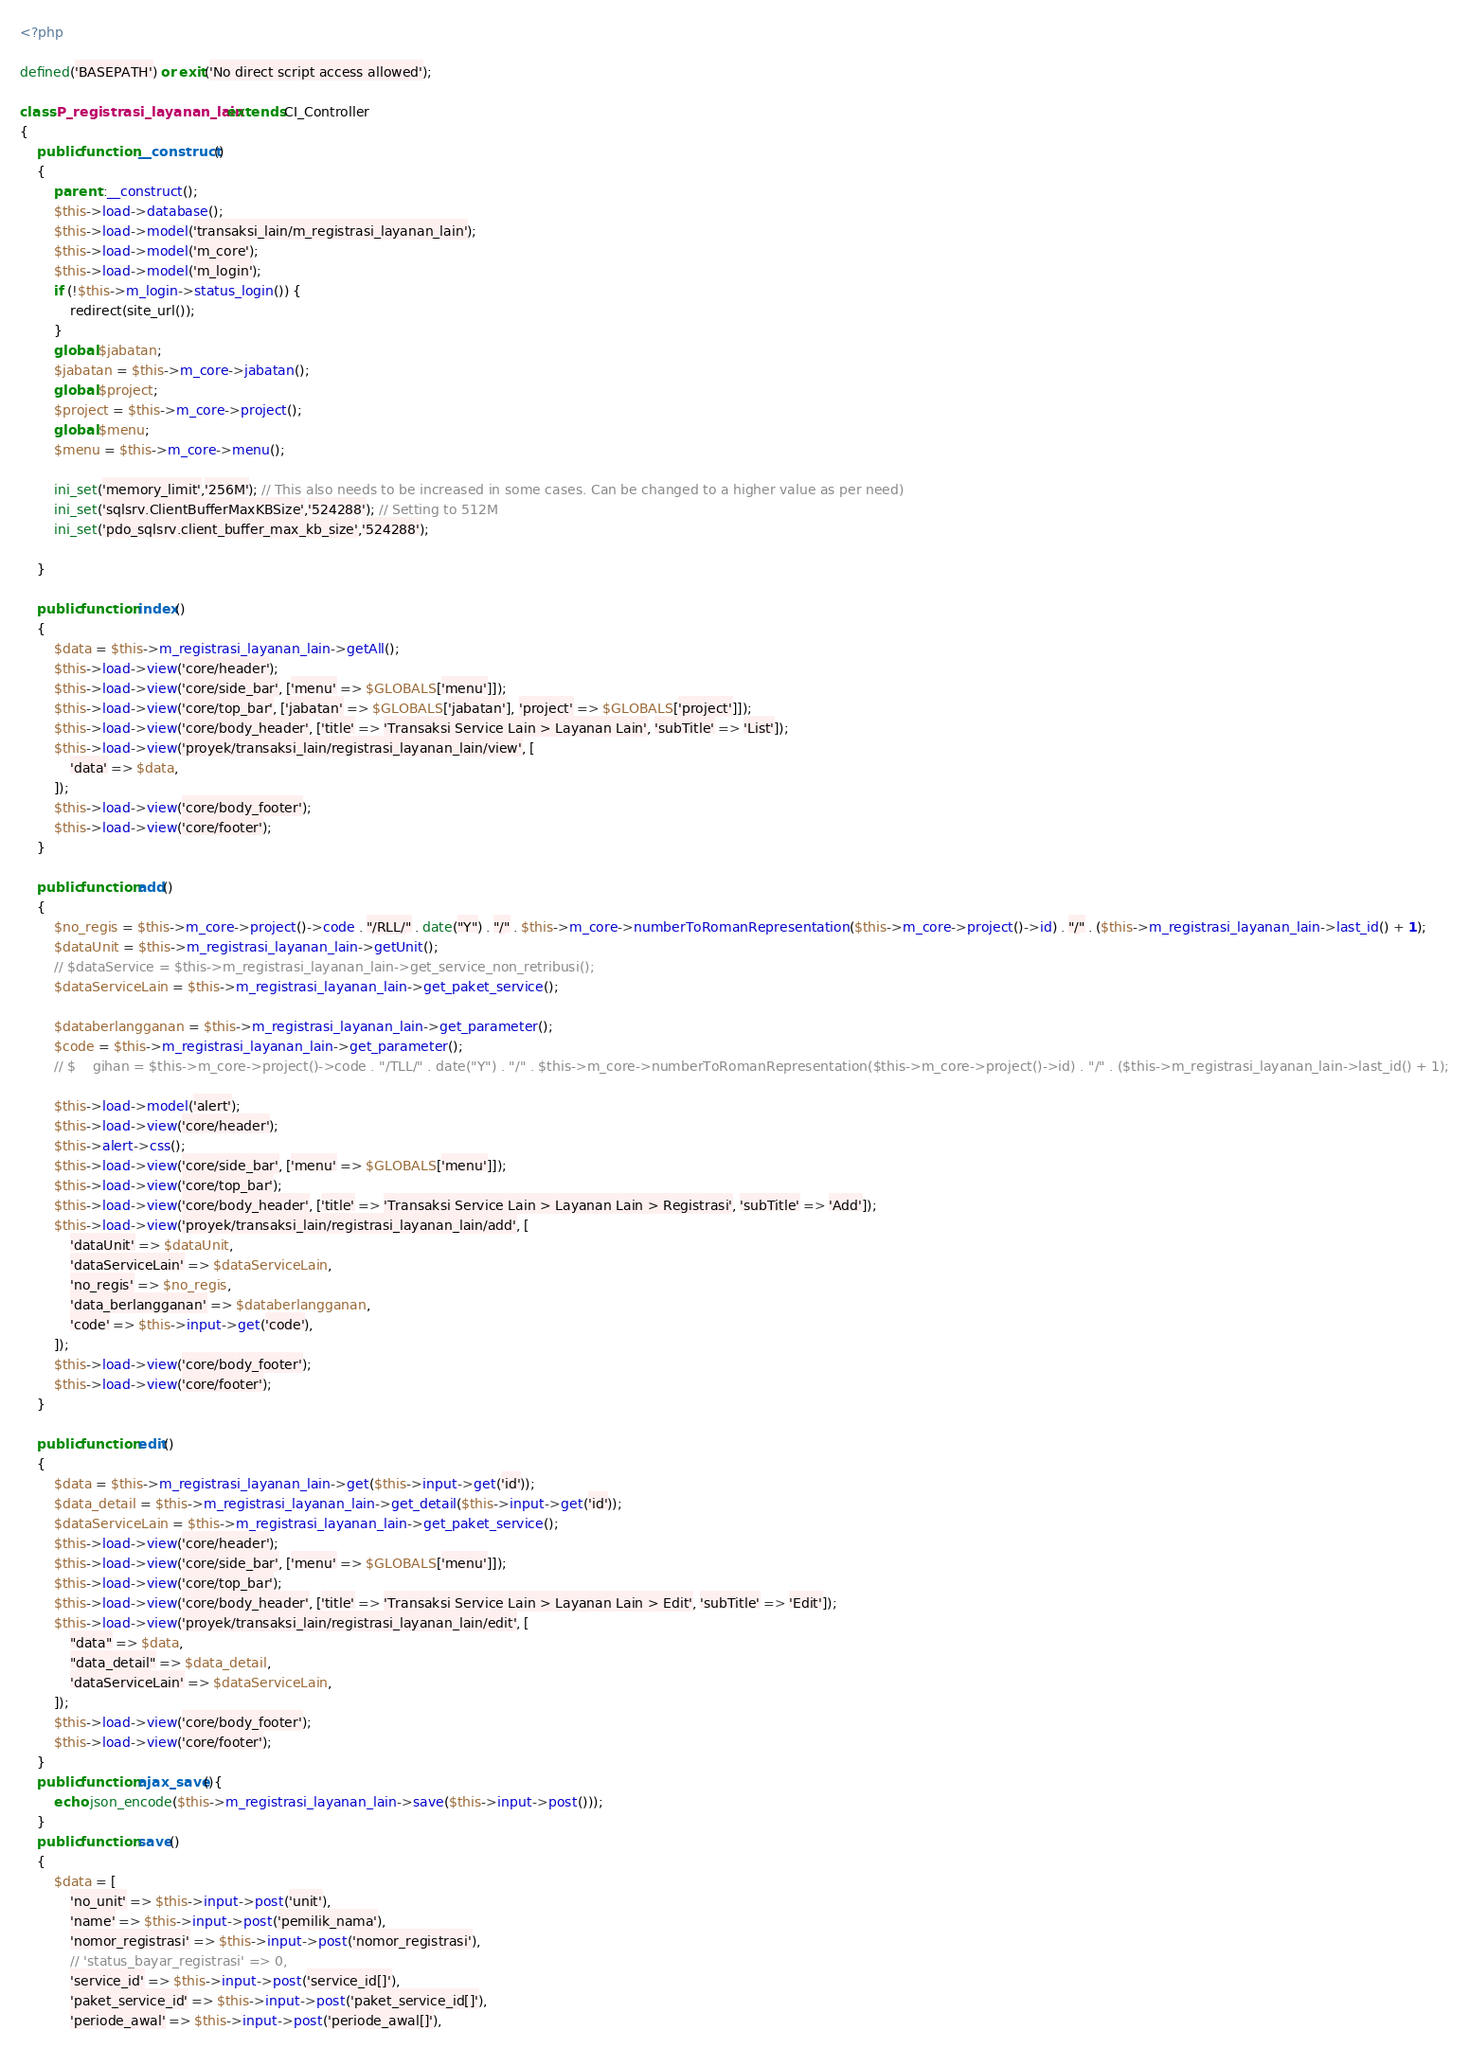Convert code to text. <code><loc_0><loc_0><loc_500><loc_500><_PHP_><?php

defined('BASEPATH') or exit('No direct script access allowed');

class P_registrasi_layanan_lain extends CI_Controller
{
    public function __construct()
    {
        parent::__construct();
        $this->load->database();
        $this->load->model('transaksi_lain/m_registrasi_layanan_lain');
        $this->load->model('m_core');
        $this->load->model('m_login');
        if (!$this->m_login->status_login()) {
            redirect(site_url());
        }
        global $jabatan;
        $jabatan = $this->m_core->jabatan();
        global $project;
        $project = $this->m_core->project();
        global $menu;
        $menu = $this->m_core->menu();
        
		ini_set('memory_limit','256M'); // This also needs to be increased in some cases. Can be changed to a higher value as per need)
        ini_set('sqlsrv.ClientBufferMaxKBSize','524288'); // Setting to 512M
        ini_set('pdo_sqlsrv.client_buffer_max_kb_size','524288');

    }

    public function index()
    {
        $data = $this->m_registrasi_layanan_lain->getAll();
        $this->load->view('core/header');
        $this->load->view('core/side_bar', ['menu' => $GLOBALS['menu']]);
        $this->load->view('core/top_bar', ['jabatan' => $GLOBALS['jabatan'], 'project' => $GLOBALS['project']]);
        $this->load->view('core/body_header', ['title' => 'Transaksi Service Lain > Layanan Lain', 'subTitle' => 'List']);
        $this->load->view('proyek/transaksi_lain/registrasi_layanan_lain/view', [
            'data' => $data,
        ]);
        $this->load->view('core/body_footer');
        $this->load->view('core/footer');
    }

    public function add()
    {
        $no_regis = $this->m_core->project()->code . "/RLL/" . date("Y") . "/" . $this->m_core->numberToRomanRepresentation($this->m_core->project()->id) . "/" . ($this->m_registrasi_layanan_lain->last_id() + 1);
        $dataUnit = $this->m_registrasi_layanan_lain->getUnit();
        // $dataService = $this->m_registrasi_layanan_lain->get_service_non_retribusi();
        $dataServiceLain = $this->m_registrasi_layanan_lain->get_paket_service();
        
        $databerlangganan = $this->m_registrasi_layanan_lain->get_parameter();
        $code = $this->m_registrasi_layanan_lain->get_parameter();
        // $    gihan = $this->m_core->project()->code . "/TLL/" . date("Y") . "/" . $this->m_core->numberToRomanRepresentation($this->m_core->project()->id) . "/" . ($this->m_registrasi_layanan_lain->last_id() + 1);
        
        $this->load->model('alert');
        $this->load->view('core/header');
        $this->alert->css();
        $this->load->view('core/side_bar', ['menu' => $GLOBALS['menu']]);
        $this->load->view('core/top_bar');
        $this->load->view('core/body_header', ['title' => 'Transaksi Service Lain > Layanan Lain > Registrasi', 'subTitle' => 'Add']);
        $this->load->view('proyek/transaksi_lain/registrasi_layanan_lain/add', [
            'dataUnit' => $dataUnit,
            'dataServiceLain' => $dataServiceLain,
            'no_regis' => $no_regis,
            'data_berlangganan' => $databerlangganan,
            'code' => $this->input->get('code'),
        ]);
        $this->load->view('core/body_footer');
        $this->load->view('core/footer');
    }
    
    public function edit()
    {
        $data = $this->m_registrasi_layanan_lain->get($this->input->get('id'));
        $data_detail = $this->m_registrasi_layanan_lain->get_detail($this->input->get('id'));
        $dataServiceLain = $this->m_registrasi_layanan_lain->get_paket_service();
        $this->load->view('core/header');
        $this->load->view('core/side_bar', ['menu' => $GLOBALS['menu']]);
        $this->load->view('core/top_bar');
        $this->load->view('core/body_header', ['title' => 'Transaksi Service Lain > Layanan Lain > Edit', 'subTitle' => 'Edit']);
        $this->load->view('proyek/transaksi_lain/registrasi_layanan_lain/edit', [
            "data" => $data,
            "data_detail" => $data_detail,
            'dataServiceLain' => $dataServiceLain,
        ]);
        $this->load->view('core/body_footer');
        $this->load->view('core/footer');
    }
    public function ajax_save(){
        echo json_encode($this->m_registrasi_layanan_lain->save($this->input->post()));
    }
    public function save()
    {
        $data = [
            'no_unit' => $this->input->post('unit'),
            'name' => $this->input->post('pemilik_nama'),
            'nomor_registrasi' => $this->input->post('nomor_registrasi'),
            // 'status_bayar_registrasi' => 0,
            'service_id' => $this->input->post('service_id[]'),
            'paket_service_id' => $this->input->post('paket_service_id[]'),
            'periode_awal' => $this->input->post('periode_awal[]'),</code> 